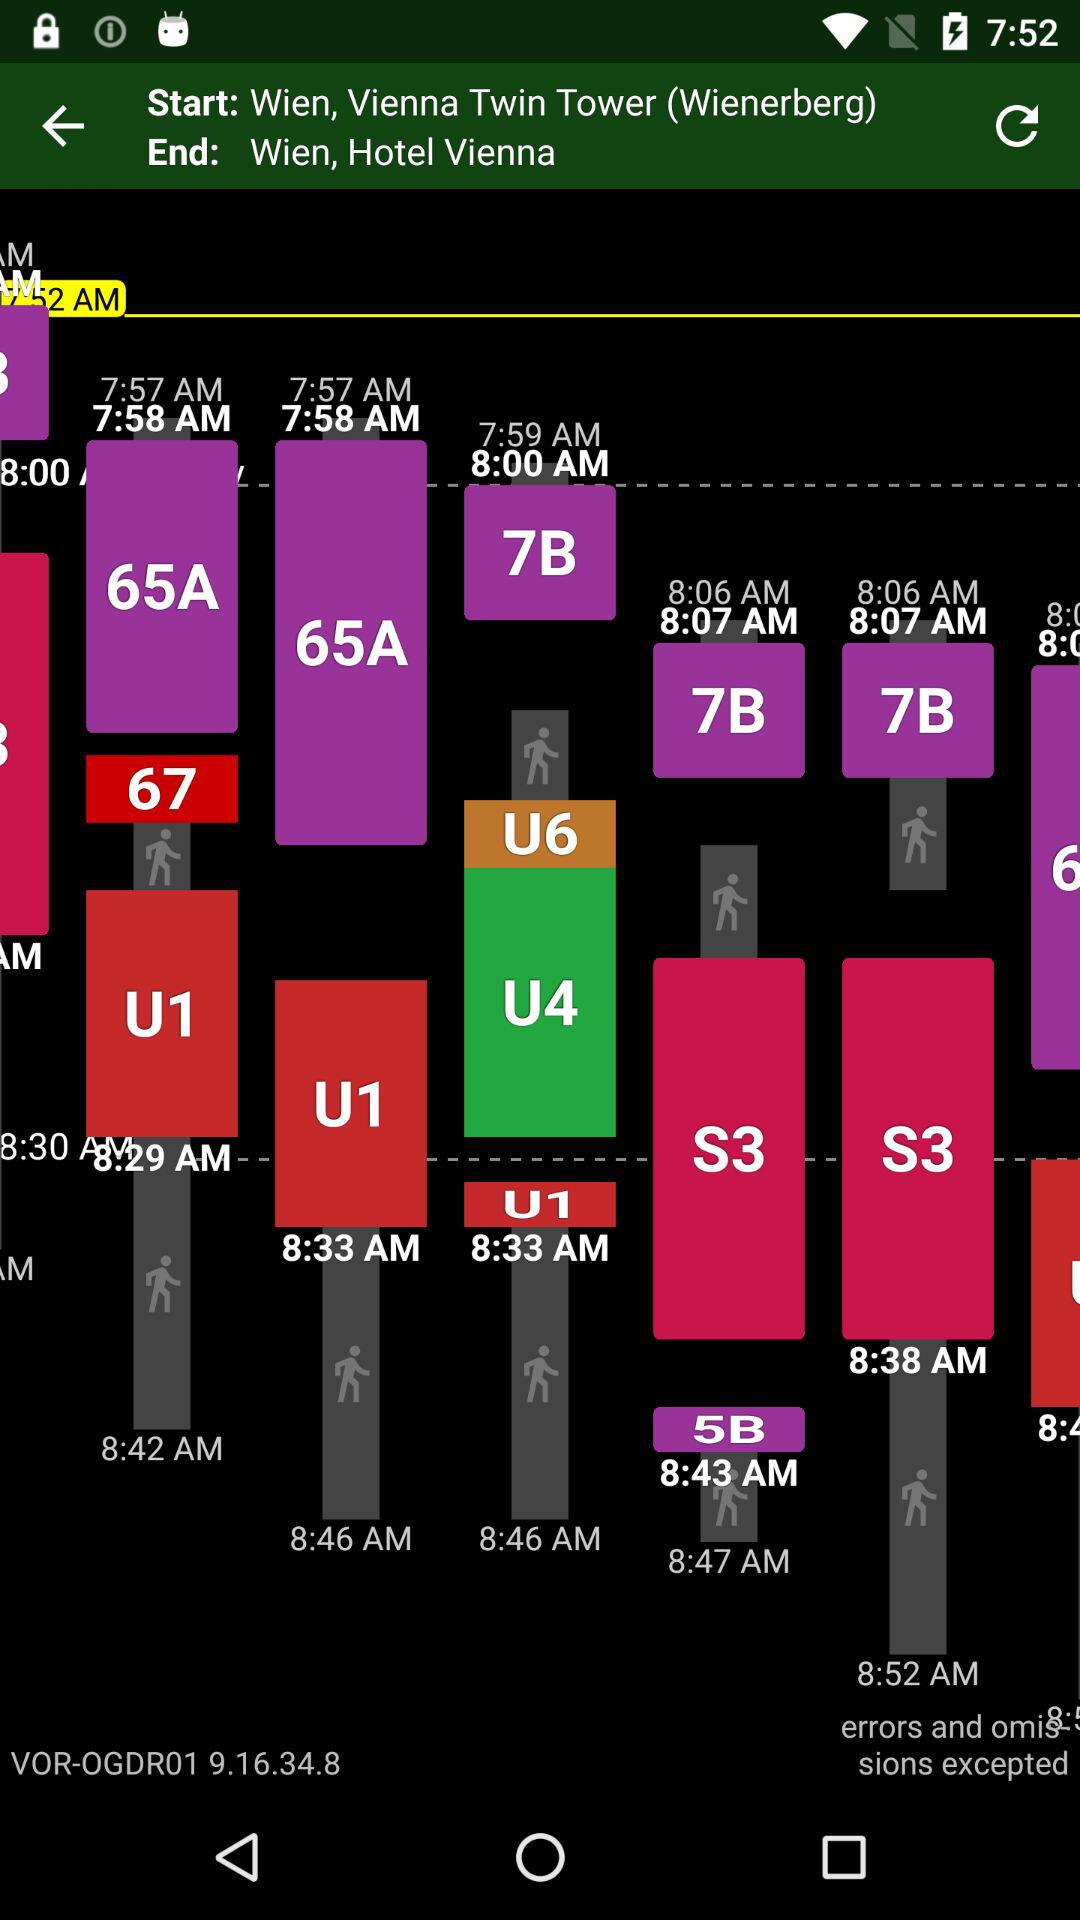What is the end location? The end location is Wien, Hotel Vienna. 